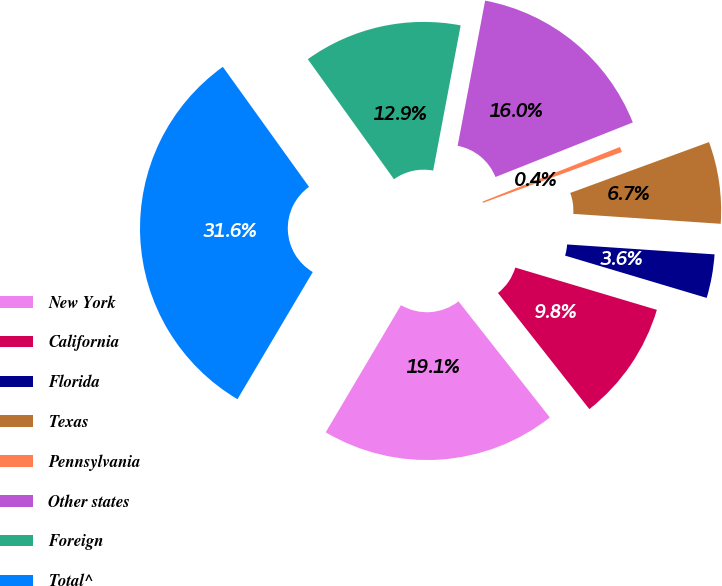Convert chart. <chart><loc_0><loc_0><loc_500><loc_500><pie_chart><fcel>New York<fcel>California<fcel>Florida<fcel>Texas<fcel>Pennsylvania<fcel>Other states<fcel>Foreign<fcel>Total^<nl><fcel>19.12%<fcel>9.77%<fcel>3.55%<fcel>6.66%<fcel>0.43%<fcel>16.0%<fcel>12.89%<fcel>31.58%<nl></chart> 